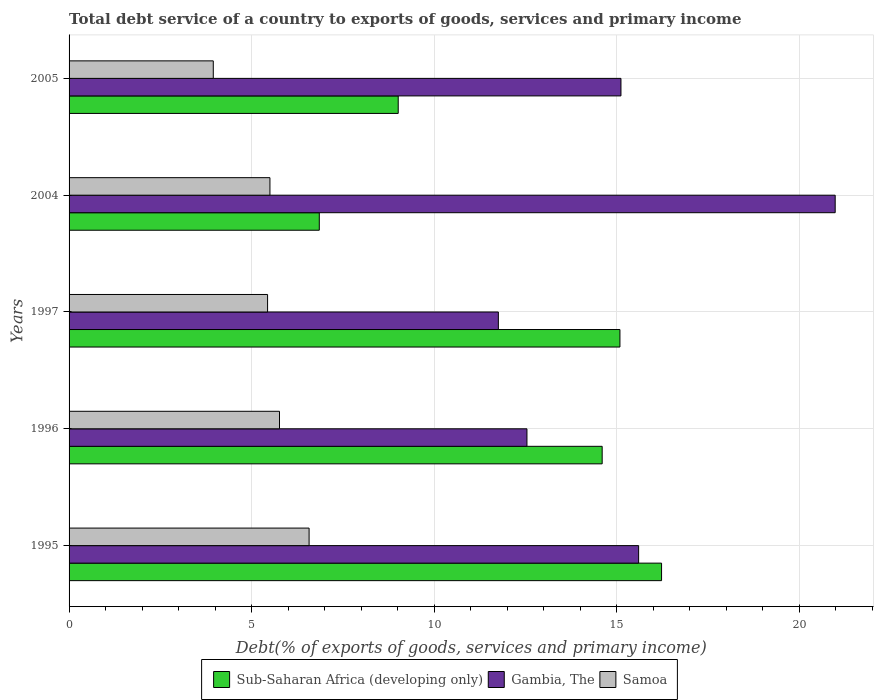Are the number of bars per tick equal to the number of legend labels?
Offer a very short reply. Yes. What is the total debt service in Sub-Saharan Africa (developing only) in 2004?
Provide a succinct answer. 6.85. Across all years, what is the maximum total debt service in Gambia, The?
Keep it short and to the point. 20.98. Across all years, what is the minimum total debt service in Samoa?
Give a very brief answer. 3.95. In which year was the total debt service in Samoa maximum?
Your answer should be very brief. 1995. In which year was the total debt service in Sub-Saharan Africa (developing only) minimum?
Your answer should be compact. 2004. What is the total total debt service in Sub-Saharan Africa (developing only) in the graph?
Provide a succinct answer. 61.79. What is the difference between the total debt service in Gambia, The in 1997 and that in 2004?
Your answer should be compact. -9.23. What is the difference between the total debt service in Sub-Saharan Africa (developing only) in 1996 and the total debt service in Samoa in 1997?
Make the answer very short. 9.16. What is the average total debt service in Samoa per year?
Provide a short and direct response. 5.45. In the year 1996, what is the difference between the total debt service in Samoa and total debt service in Sub-Saharan Africa (developing only)?
Provide a short and direct response. -8.84. In how many years, is the total debt service in Sub-Saharan Africa (developing only) greater than 17 %?
Keep it short and to the point. 0. What is the ratio of the total debt service in Samoa in 2004 to that in 2005?
Your response must be concise. 1.39. Is the total debt service in Sub-Saharan Africa (developing only) in 1995 less than that in 1997?
Ensure brevity in your answer.  No. What is the difference between the highest and the second highest total debt service in Sub-Saharan Africa (developing only)?
Offer a terse response. 1.14. What is the difference between the highest and the lowest total debt service in Samoa?
Your answer should be compact. 2.62. Is the sum of the total debt service in Gambia, The in 1996 and 2004 greater than the maximum total debt service in Samoa across all years?
Make the answer very short. Yes. What does the 2nd bar from the top in 2004 represents?
Make the answer very short. Gambia, The. What does the 1st bar from the bottom in 2004 represents?
Your answer should be compact. Sub-Saharan Africa (developing only). Is it the case that in every year, the sum of the total debt service in Sub-Saharan Africa (developing only) and total debt service in Samoa is greater than the total debt service in Gambia, The?
Give a very brief answer. No. Are all the bars in the graph horizontal?
Offer a very short reply. Yes. What is the difference between two consecutive major ticks on the X-axis?
Offer a very short reply. 5. Are the values on the major ticks of X-axis written in scientific E-notation?
Your answer should be very brief. No. Where does the legend appear in the graph?
Offer a very short reply. Bottom center. How many legend labels are there?
Keep it short and to the point. 3. What is the title of the graph?
Your answer should be compact. Total debt service of a country to exports of goods, services and primary income. What is the label or title of the X-axis?
Give a very brief answer. Debt(% of exports of goods, services and primary income). What is the Debt(% of exports of goods, services and primary income) of Sub-Saharan Africa (developing only) in 1995?
Your answer should be compact. 16.23. What is the Debt(% of exports of goods, services and primary income) of Gambia, The in 1995?
Keep it short and to the point. 15.6. What is the Debt(% of exports of goods, services and primary income) in Samoa in 1995?
Make the answer very short. 6.57. What is the Debt(% of exports of goods, services and primary income) in Sub-Saharan Africa (developing only) in 1996?
Make the answer very short. 14.6. What is the Debt(% of exports of goods, services and primary income) in Gambia, The in 1996?
Your response must be concise. 12.54. What is the Debt(% of exports of goods, services and primary income) of Samoa in 1996?
Give a very brief answer. 5.76. What is the Debt(% of exports of goods, services and primary income) in Sub-Saharan Africa (developing only) in 1997?
Provide a short and direct response. 15.09. What is the Debt(% of exports of goods, services and primary income) of Gambia, The in 1997?
Provide a short and direct response. 11.76. What is the Debt(% of exports of goods, services and primary income) in Samoa in 1997?
Offer a very short reply. 5.44. What is the Debt(% of exports of goods, services and primary income) of Sub-Saharan Africa (developing only) in 2004?
Make the answer very short. 6.85. What is the Debt(% of exports of goods, services and primary income) in Gambia, The in 2004?
Ensure brevity in your answer.  20.98. What is the Debt(% of exports of goods, services and primary income) of Samoa in 2004?
Ensure brevity in your answer.  5.5. What is the Debt(% of exports of goods, services and primary income) in Sub-Saharan Africa (developing only) in 2005?
Provide a short and direct response. 9.02. What is the Debt(% of exports of goods, services and primary income) of Gambia, The in 2005?
Make the answer very short. 15.12. What is the Debt(% of exports of goods, services and primary income) in Samoa in 2005?
Give a very brief answer. 3.95. Across all years, what is the maximum Debt(% of exports of goods, services and primary income) in Sub-Saharan Africa (developing only)?
Offer a very short reply. 16.23. Across all years, what is the maximum Debt(% of exports of goods, services and primary income) in Gambia, The?
Offer a very short reply. 20.98. Across all years, what is the maximum Debt(% of exports of goods, services and primary income) of Samoa?
Offer a very short reply. 6.57. Across all years, what is the minimum Debt(% of exports of goods, services and primary income) in Sub-Saharan Africa (developing only)?
Keep it short and to the point. 6.85. Across all years, what is the minimum Debt(% of exports of goods, services and primary income) in Gambia, The?
Your answer should be very brief. 11.76. Across all years, what is the minimum Debt(% of exports of goods, services and primary income) of Samoa?
Your response must be concise. 3.95. What is the total Debt(% of exports of goods, services and primary income) in Sub-Saharan Africa (developing only) in the graph?
Your answer should be compact. 61.79. What is the total Debt(% of exports of goods, services and primary income) of Gambia, The in the graph?
Your answer should be very brief. 76. What is the total Debt(% of exports of goods, services and primary income) in Samoa in the graph?
Offer a very short reply. 27.23. What is the difference between the Debt(% of exports of goods, services and primary income) in Sub-Saharan Africa (developing only) in 1995 and that in 1996?
Make the answer very short. 1.63. What is the difference between the Debt(% of exports of goods, services and primary income) of Gambia, The in 1995 and that in 1996?
Keep it short and to the point. 3.06. What is the difference between the Debt(% of exports of goods, services and primary income) in Samoa in 1995 and that in 1996?
Provide a short and direct response. 0.81. What is the difference between the Debt(% of exports of goods, services and primary income) of Sub-Saharan Africa (developing only) in 1995 and that in 1997?
Give a very brief answer. 1.14. What is the difference between the Debt(% of exports of goods, services and primary income) in Gambia, The in 1995 and that in 1997?
Your answer should be very brief. 3.84. What is the difference between the Debt(% of exports of goods, services and primary income) in Samoa in 1995 and that in 1997?
Offer a terse response. 1.14. What is the difference between the Debt(% of exports of goods, services and primary income) in Sub-Saharan Africa (developing only) in 1995 and that in 2004?
Offer a very short reply. 9.37. What is the difference between the Debt(% of exports of goods, services and primary income) of Gambia, The in 1995 and that in 2004?
Offer a very short reply. -5.38. What is the difference between the Debt(% of exports of goods, services and primary income) of Samoa in 1995 and that in 2004?
Provide a succinct answer. 1.07. What is the difference between the Debt(% of exports of goods, services and primary income) of Sub-Saharan Africa (developing only) in 1995 and that in 2005?
Give a very brief answer. 7.21. What is the difference between the Debt(% of exports of goods, services and primary income) in Gambia, The in 1995 and that in 2005?
Your response must be concise. 0.48. What is the difference between the Debt(% of exports of goods, services and primary income) in Samoa in 1995 and that in 2005?
Make the answer very short. 2.62. What is the difference between the Debt(% of exports of goods, services and primary income) in Sub-Saharan Africa (developing only) in 1996 and that in 1997?
Your answer should be very brief. -0.49. What is the difference between the Debt(% of exports of goods, services and primary income) of Gambia, The in 1996 and that in 1997?
Offer a very short reply. 0.78. What is the difference between the Debt(% of exports of goods, services and primary income) of Samoa in 1996 and that in 1997?
Your answer should be very brief. 0.33. What is the difference between the Debt(% of exports of goods, services and primary income) of Sub-Saharan Africa (developing only) in 1996 and that in 2004?
Give a very brief answer. 7.75. What is the difference between the Debt(% of exports of goods, services and primary income) in Gambia, The in 1996 and that in 2004?
Your answer should be very brief. -8.44. What is the difference between the Debt(% of exports of goods, services and primary income) in Samoa in 1996 and that in 2004?
Make the answer very short. 0.26. What is the difference between the Debt(% of exports of goods, services and primary income) in Sub-Saharan Africa (developing only) in 1996 and that in 2005?
Your answer should be compact. 5.59. What is the difference between the Debt(% of exports of goods, services and primary income) of Gambia, The in 1996 and that in 2005?
Keep it short and to the point. -2.57. What is the difference between the Debt(% of exports of goods, services and primary income) in Samoa in 1996 and that in 2005?
Your response must be concise. 1.81. What is the difference between the Debt(% of exports of goods, services and primary income) in Sub-Saharan Africa (developing only) in 1997 and that in 2004?
Ensure brevity in your answer.  8.23. What is the difference between the Debt(% of exports of goods, services and primary income) in Gambia, The in 1997 and that in 2004?
Make the answer very short. -9.23. What is the difference between the Debt(% of exports of goods, services and primary income) of Samoa in 1997 and that in 2004?
Make the answer very short. -0.06. What is the difference between the Debt(% of exports of goods, services and primary income) of Sub-Saharan Africa (developing only) in 1997 and that in 2005?
Your answer should be compact. 6.07. What is the difference between the Debt(% of exports of goods, services and primary income) in Gambia, The in 1997 and that in 2005?
Keep it short and to the point. -3.36. What is the difference between the Debt(% of exports of goods, services and primary income) of Samoa in 1997 and that in 2005?
Ensure brevity in your answer.  1.49. What is the difference between the Debt(% of exports of goods, services and primary income) in Sub-Saharan Africa (developing only) in 2004 and that in 2005?
Ensure brevity in your answer.  -2.16. What is the difference between the Debt(% of exports of goods, services and primary income) in Gambia, The in 2004 and that in 2005?
Provide a succinct answer. 5.87. What is the difference between the Debt(% of exports of goods, services and primary income) of Samoa in 2004 and that in 2005?
Your answer should be compact. 1.55. What is the difference between the Debt(% of exports of goods, services and primary income) of Sub-Saharan Africa (developing only) in 1995 and the Debt(% of exports of goods, services and primary income) of Gambia, The in 1996?
Provide a short and direct response. 3.69. What is the difference between the Debt(% of exports of goods, services and primary income) in Sub-Saharan Africa (developing only) in 1995 and the Debt(% of exports of goods, services and primary income) in Samoa in 1996?
Your answer should be very brief. 10.46. What is the difference between the Debt(% of exports of goods, services and primary income) of Gambia, The in 1995 and the Debt(% of exports of goods, services and primary income) of Samoa in 1996?
Offer a terse response. 9.84. What is the difference between the Debt(% of exports of goods, services and primary income) of Sub-Saharan Africa (developing only) in 1995 and the Debt(% of exports of goods, services and primary income) of Gambia, The in 1997?
Make the answer very short. 4.47. What is the difference between the Debt(% of exports of goods, services and primary income) of Sub-Saharan Africa (developing only) in 1995 and the Debt(% of exports of goods, services and primary income) of Samoa in 1997?
Your answer should be very brief. 10.79. What is the difference between the Debt(% of exports of goods, services and primary income) in Gambia, The in 1995 and the Debt(% of exports of goods, services and primary income) in Samoa in 1997?
Your response must be concise. 10.16. What is the difference between the Debt(% of exports of goods, services and primary income) of Sub-Saharan Africa (developing only) in 1995 and the Debt(% of exports of goods, services and primary income) of Gambia, The in 2004?
Provide a succinct answer. -4.76. What is the difference between the Debt(% of exports of goods, services and primary income) of Sub-Saharan Africa (developing only) in 1995 and the Debt(% of exports of goods, services and primary income) of Samoa in 2004?
Provide a succinct answer. 10.73. What is the difference between the Debt(% of exports of goods, services and primary income) of Gambia, The in 1995 and the Debt(% of exports of goods, services and primary income) of Samoa in 2004?
Your response must be concise. 10.1. What is the difference between the Debt(% of exports of goods, services and primary income) in Sub-Saharan Africa (developing only) in 1995 and the Debt(% of exports of goods, services and primary income) in Gambia, The in 2005?
Your answer should be very brief. 1.11. What is the difference between the Debt(% of exports of goods, services and primary income) in Sub-Saharan Africa (developing only) in 1995 and the Debt(% of exports of goods, services and primary income) in Samoa in 2005?
Your answer should be very brief. 12.28. What is the difference between the Debt(% of exports of goods, services and primary income) of Gambia, The in 1995 and the Debt(% of exports of goods, services and primary income) of Samoa in 2005?
Your answer should be compact. 11.65. What is the difference between the Debt(% of exports of goods, services and primary income) of Sub-Saharan Africa (developing only) in 1996 and the Debt(% of exports of goods, services and primary income) of Gambia, The in 1997?
Ensure brevity in your answer.  2.84. What is the difference between the Debt(% of exports of goods, services and primary income) in Sub-Saharan Africa (developing only) in 1996 and the Debt(% of exports of goods, services and primary income) in Samoa in 1997?
Ensure brevity in your answer.  9.16. What is the difference between the Debt(% of exports of goods, services and primary income) of Gambia, The in 1996 and the Debt(% of exports of goods, services and primary income) of Samoa in 1997?
Your answer should be compact. 7.1. What is the difference between the Debt(% of exports of goods, services and primary income) in Sub-Saharan Africa (developing only) in 1996 and the Debt(% of exports of goods, services and primary income) in Gambia, The in 2004?
Keep it short and to the point. -6.38. What is the difference between the Debt(% of exports of goods, services and primary income) of Sub-Saharan Africa (developing only) in 1996 and the Debt(% of exports of goods, services and primary income) of Samoa in 2004?
Provide a succinct answer. 9.1. What is the difference between the Debt(% of exports of goods, services and primary income) of Gambia, The in 1996 and the Debt(% of exports of goods, services and primary income) of Samoa in 2004?
Give a very brief answer. 7.04. What is the difference between the Debt(% of exports of goods, services and primary income) of Sub-Saharan Africa (developing only) in 1996 and the Debt(% of exports of goods, services and primary income) of Gambia, The in 2005?
Ensure brevity in your answer.  -0.51. What is the difference between the Debt(% of exports of goods, services and primary income) of Sub-Saharan Africa (developing only) in 1996 and the Debt(% of exports of goods, services and primary income) of Samoa in 2005?
Provide a succinct answer. 10.65. What is the difference between the Debt(% of exports of goods, services and primary income) of Gambia, The in 1996 and the Debt(% of exports of goods, services and primary income) of Samoa in 2005?
Offer a very short reply. 8.59. What is the difference between the Debt(% of exports of goods, services and primary income) in Sub-Saharan Africa (developing only) in 1997 and the Debt(% of exports of goods, services and primary income) in Gambia, The in 2004?
Offer a terse response. -5.9. What is the difference between the Debt(% of exports of goods, services and primary income) of Sub-Saharan Africa (developing only) in 1997 and the Debt(% of exports of goods, services and primary income) of Samoa in 2004?
Provide a succinct answer. 9.59. What is the difference between the Debt(% of exports of goods, services and primary income) of Gambia, The in 1997 and the Debt(% of exports of goods, services and primary income) of Samoa in 2004?
Ensure brevity in your answer.  6.26. What is the difference between the Debt(% of exports of goods, services and primary income) in Sub-Saharan Africa (developing only) in 1997 and the Debt(% of exports of goods, services and primary income) in Gambia, The in 2005?
Give a very brief answer. -0.03. What is the difference between the Debt(% of exports of goods, services and primary income) of Sub-Saharan Africa (developing only) in 1997 and the Debt(% of exports of goods, services and primary income) of Samoa in 2005?
Your answer should be compact. 11.14. What is the difference between the Debt(% of exports of goods, services and primary income) of Gambia, The in 1997 and the Debt(% of exports of goods, services and primary income) of Samoa in 2005?
Provide a short and direct response. 7.81. What is the difference between the Debt(% of exports of goods, services and primary income) of Sub-Saharan Africa (developing only) in 2004 and the Debt(% of exports of goods, services and primary income) of Gambia, The in 2005?
Ensure brevity in your answer.  -8.26. What is the difference between the Debt(% of exports of goods, services and primary income) of Sub-Saharan Africa (developing only) in 2004 and the Debt(% of exports of goods, services and primary income) of Samoa in 2005?
Your answer should be very brief. 2.9. What is the difference between the Debt(% of exports of goods, services and primary income) in Gambia, The in 2004 and the Debt(% of exports of goods, services and primary income) in Samoa in 2005?
Your response must be concise. 17.03. What is the average Debt(% of exports of goods, services and primary income) of Sub-Saharan Africa (developing only) per year?
Ensure brevity in your answer.  12.36. What is the average Debt(% of exports of goods, services and primary income) of Gambia, The per year?
Provide a succinct answer. 15.2. What is the average Debt(% of exports of goods, services and primary income) in Samoa per year?
Your answer should be very brief. 5.45. In the year 1995, what is the difference between the Debt(% of exports of goods, services and primary income) of Sub-Saharan Africa (developing only) and Debt(% of exports of goods, services and primary income) of Gambia, The?
Offer a very short reply. 0.63. In the year 1995, what is the difference between the Debt(% of exports of goods, services and primary income) in Sub-Saharan Africa (developing only) and Debt(% of exports of goods, services and primary income) in Samoa?
Offer a very short reply. 9.65. In the year 1995, what is the difference between the Debt(% of exports of goods, services and primary income) in Gambia, The and Debt(% of exports of goods, services and primary income) in Samoa?
Make the answer very short. 9.03. In the year 1996, what is the difference between the Debt(% of exports of goods, services and primary income) in Sub-Saharan Africa (developing only) and Debt(% of exports of goods, services and primary income) in Gambia, The?
Make the answer very short. 2.06. In the year 1996, what is the difference between the Debt(% of exports of goods, services and primary income) of Sub-Saharan Africa (developing only) and Debt(% of exports of goods, services and primary income) of Samoa?
Your answer should be very brief. 8.84. In the year 1996, what is the difference between the Debt(% of exports of goods, services and primary income) in Gambia, The and Debt(% of exports of goods, services and primary income) in Samoa?
Your answer should be very brief. 6.78. In the year 1997, what is the difference between the Debt(% of exports of goods, services and primary income) in Sub-Saharan Africa (developing only) and Debt(% of exports of goods, services and primary income) in Gambia, The?
Provide a succinct answer. 3.33. In the year 1997, what is the difference between the Debt(% of exports of goods, services and primary income) in Sub-Saharan Africa (developing only) and Debt(% of exports of goods, services and primary income) in Samoa?
Make the answer very short. 9.65. In the year 1997, what is the difference between the Debt(% of exports of goods, services and primary income) in Gambia, The and Debt(% of exports of goods, services and primary income) in Samoa?
Ensure brevity in your answer.  6.32. In the year 2004, what is the difference between the Debt(% of exports of goods, services and primary income) of Sub-Saharan Africa (developing only) and Debt(% of exports of goods, services and primary income) of Gambia, The?
Make the answer very short. -14.13. In the year 2004, what is the difference between the Debt(% of exports of goods, services and primary income) in Sub-Saharan Africa (developing only) and Debt(% of exports of goods, services and primary income) in Samoa?
Ensure brevity in your answer.  1.35. In the year 2004, what is the difference between the Debt(% of exports of goods, services and primary income) in Gambia, The and Debt(% of exports of goods, services and primary income) in Samoa?
Ensure brevity in your answer.  15.48. In the year 2005, what is the difference between the Debt(% of exports of goods, services and primary income) in Sub-Saharan Africa (developing only) and Debt(% of exports of goods, services and primary income) in Gambia, The?
Provide a succinct answer. -6.1. In the year 2005, what is the difference between the Debt(% of exports of goods, services and primary income) in Sub-Saharan Africa (developing only) and Debt(% of exports of goods, services and primary income) in Samoa?
Offer a very short reply. 5.07. In the year 2005, what is the difference between the Debt(% of exports of goods, services and primary income) in Gambia, The and Debt(% of exports of goods, services and primary income) in Samoa?
Your response must be concise. 11.17. What is the ratio of the Debt(% of exports of goods, services and primary income) of Sub-Saharan Africa (developing only) in 1995 to that in 1996?
Provide a succinct answer. 1.11. What is the ratio of the Debt(% of exports of goods, services and primary income) of Gambia, The in 1995 to that in 1996?
Give a very brief answer. 1.24. What is the ratio of the Debt(% of exports of goods, services and primary income) in Samoa in 1995 to that in 1996?
Offer a terse response. 1.14. What is the ratio of the Debt(% of exports of goods, services and primary income) in Sub-Saharan Africa (developing only) in 1995 to that in 1997?
Ensure brevity in your answer.  1.08. What is the ratio of the Debt(% of exports of goods, services and primary income) of Gambia, The in 1995 to that in 1997?
Give a very brief answer. 1.33. What is the ratio of the Debt(% of exports of goods, services and primary income) in Samoa in 1995 to that in 1997?
Give a very brief answer. 1.21. What is the ratio of the Debt(% of exports of goods, services and primary income) in Sub-Saharan Africa (developing only) in 1995 to that in 2004?
Ensure brevity in your answer.  2.37. What is the ratio of the Debt(% of exports of goods, services and primary income) in Gambia, The in 1995 to that in 2004?
Ensure brevity in your answer.  0.74. What is the ratio of the Debt(% of exports of goods, services and primary income) of Samoa in 1995 to that in 2004?
Give a very brief answer. 1.19. What is the ratio of the Debt(% of exports of goods, services and primary income) of Sub-Saharan Africa (developing only) in 1995 to that in 2005?
Your answer should be very brief. 1.8. What is the ratio of the Debt(% of exports of goods, services and primary income) of Gambia, The in 1995 to that in 2005?
Give a very brief answer. 1.03. What is the ratio of the Debt(% of exports of goods, services and primary income) in Samoa in 1995 to that in 2005?
Your answer should be very brief. 1.66. What is the ratio of the Debt(% of exports of goods, services and primary income) in Sub-Saharan Africa (developing only) in 1996 to that in 1997?
Provide a short and direct response. 0.97. What is the ratio of the Debt(% of exports of goods, services and primary income) of Gambia, The in 1996 to that in 1997?
Provide a succinct answer. 1.07. What is the ratio of the Debt(% of exports of goods, services and primary income) of Samoa in 1996 to that in 1997?
Make the answer very short. 1.06. What is the ratio of the Debt(% of exports of goods, services and primary income) in Sub-Saharan Africa (developing only) in 1996 to that in 2004?
Make the answer very short. 2.13. What is the ratio of the Debt(% of exports of goods, services and primary income) of Gambia, The in 1996 to that in 2004?
Provide a succinct answer. 0.6. What is the ratio of the Debt(% of exports of goods, services and primary income) in Samoa in 1996 to that in 2004?
Your answer should be very brief. 1.05. What is the ratio of the Debt(% of exports of goods, services and primary income) of Sub-Saharan Africa (developing only) in 1996 to that in 2005?
Offer a terse response. 1.62. What is the ratio of the Debt(% of exports of goods, services and primary income) of Gambia, The in 1996 to that in 2005?
Provide a short and direct response. 0.83. What is the ratio of the Debt(% of exports of goods, services and primary income) of Samoa in 1996 to that in 2005?
Give a very brief answer. 1.46. What is the ratio of the Debt(% of exports of goods, services and primary income) in Sub-Saharan Africa (developing only) in 1997 to that in 2004?
Your answer should be very brief. 2.2. What is the ratio of the Debt(% of exports of goods, services and primary income) of Gambia, The in 1997 to that in 2004?
Give a very brief answer. 0.56. What is the ratio of the Debt(% of exports of goods, services and primary income) of Sub-Saharan Africa (developing only) in 1997 to that in 2005?
Provide a short and direct response. 1.67. What is the ratio of the Debt(% of exports of goods, services and primary income) in Gambia, The in 1997 to that in 2005?
Ensure brevity in your answer.  0.78. What is the ratio of the Debt(% of exports of goods, services and primary income) in Samoa in 1997 to that in 2005?
Your answer should be compact. 1.38. What is the ratio of the Debt(% of exports of goods, services and primary income) of Sub-Saharan Africa (developing only) in 2004 to that in 2005?
Your response must be concise. 0.76. What is the ratio of the Debt(% of exports of goods, services and primary income) of Gambia, The in 2004 to that in 2005?
Your response must be concise. 1.39. What is the ratio of the Debt(% of exports of goods, services and primary income) of Samoa in 2004 to that in 2005?
Offer a terse response. 1.39. What is the difference between the highest and the second highest Debt(% of exports of goods, services and primary income) in Sub-Saharan Africa (developing only)?
Your response must be concise. 1.14. What is the difference between the highest and the second highest Debt(% of exports of goods, services and primary income) of Gambia, The?
Offer a very short reply. 5.38. What is the difference between the highest and the second highest Debt(% of exports of goods, services and primary income) of Samoa?
Offer a terse response. 0.81. What is the difference between the highest and the lowest Debt(% of exports of goods, services and primary income) of Sub-Saharan Africa (developing only)?
Offer a terse response. 9.37. What is the difference between the highest and the lowest Debt(% of exports of goods, services and primary income) of Gambia, The?
Make the answer very short. 9.23. What is the difference between the highest and the lowest Debt(% of exports of goods, services and primary income) in Samoa?
Give a very brief answer. 2.62. 